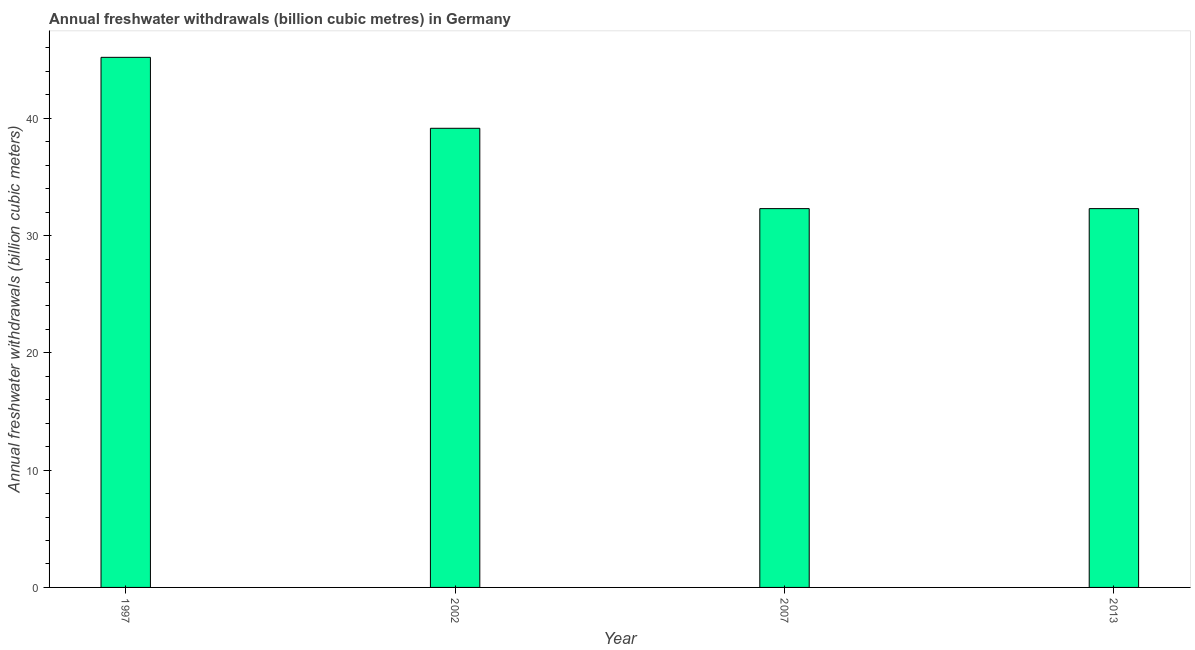Does the graph contain any zero values?
Offer a very short reply. No. Does the graph contain grids?
Provide a short and direct response. No. What is the title of the graph?
Provide a short and direct response. Annual freshwater withdrawals (billion cubic metres) in Germany. What is the label or title of the X-axis?
Your answer should be very brief. Year. What is the label or title of the Y-axis?
Ensure brevity in your answer.  Annual freshwater withdrawals (billion cubic meters). What is the annual freshwater withdrawals in 2002?
Provide a short and direct response. 39.15. Across all years, what is the maximum annual freshwater withdrawals?
Offer a terse response. 45.2. Across all years, what is the minimum annual freshwater withdrawals?
Make the answer very short. 32.3. In which year was the annual freshwater withdrawals maximum?
Ensure brevity in your answer.  1997. What is the sum of the annual freshwater withdrawals?
Keep it short and to the point. 148.95. What is the difference between the annual freshwater withdrawals in 2007 and 2013?
Provide a succinct answer. 0. What is the average annual freshwater withdrawals per year?
Keep it short and to the point. 37.24. What is the median annual freshwater withdrawals?
Offer a terse response. 35.72. Do a majority of the years between 2007 and 1997 (inclusive) have annual freshwater withdrawals greater than 40 billion cubic meters?
Ensure brevity in your answer.  Yes. What is the ratio of the annual freshwater withdrawals in 2002 to that in 2007?
Keep it short and to the point. 1.21. Is the difference between the annual freshwater withdrawals in 2007 and 2013 greater than the difference between any two years?
Make the answer very short. No. What is the difference between the highest and the second highest annual freshwater withdrawals?
Provide a succinct answer. 6.05. What is the difference between the highest and the lowest annual freshwater withdrawals?
Keep it short and to the point. 12.9. Are all the bars in the graph horizontal?
Ensure brevity in your answer.  No. What is the difference between two consecutive major ticks on the Y-axis?
Ensure brevity in your answer.  10. What is the Annual freshwater withdrawals (billion cubic meters) of 1997?
Offer a very short reply. 45.2. What is the Annual freshwater withdrawals (billion cubic meters) of 2002?
Keep it short and to the point. 39.15. What is the Annual freshwater withdrawals (billion cubic meters) in 2007?
Give a very brief answer. 32.3. What is the Annual freshwater withdrawals (billion cubic meters) in 2013?
Keep it short and to the point. 32.3. What is the difference between the Annual freshwater withdrawals (billion cubic meters) in 1997 and 2002?
Offer a very short reply. 6.05. What is the difference between the Annual freshwater withdrawals (billion cubic meters) in 1997 and 2013?
Your answer should be very brief. 12.9. What is the difference between the Annual freshwater withdrawals (billion cubic meters) in 2002 and 2007?
Provide a short and direct response. 6.85. What is the difference between the Annual freshwater withdrawals (billion cubic meters) in 2002 and 2013?
Ensure brevity in your answer.  6.85. What is the ratio of the Annual freshwater withdrawals (billion cubic meters) in 1997 to that in 2002?
Your answer should be compact. 1.16. What is the ratio of the Annual freshwater withdrawals (billion cubic meters) in 1997 to that in 2007?
Give a very brief answer. 1.4. What is the ratio of the Annual freshwater withdrawals (billion cubic meters) in 1997 to that in 2013?
Offer a terse response. 1.4. What is the ratio of the Annual freshwater withdrawals (billion cubic meters) in 2002 to that in 2007?
Offer a terse response. 1.21. What is the ratio of the Annual freshwater withdrawals (billion cubic meters) in 2002 to that in 2013?
Give a very brief answer. 1.21. 